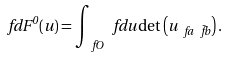Convert formula to latex. <formula><loc_0><loc_0><loc_500><loc_500>\ f d F ^ { 0 } ( u ) = \int _ { \ f O } \ f d u \det \left ( u _ { \ f a \bar { \ f b } } \right ) .</formula> 